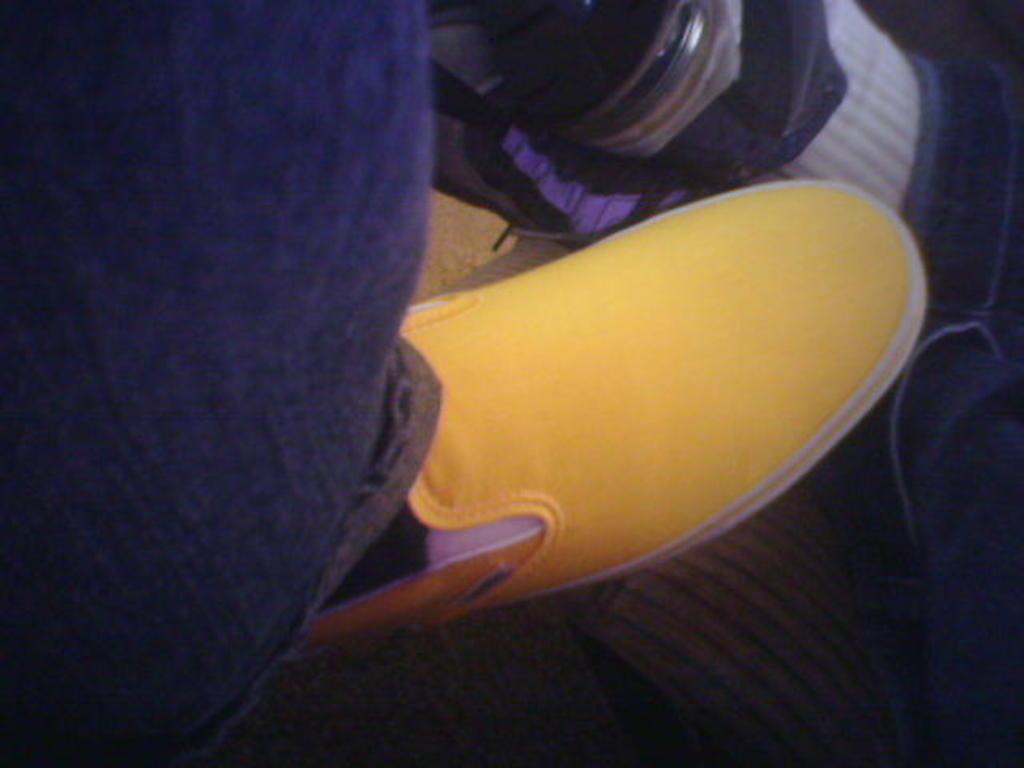Describe this image in one or two sentences. In this image we can see a person leg with yellow shoe. 